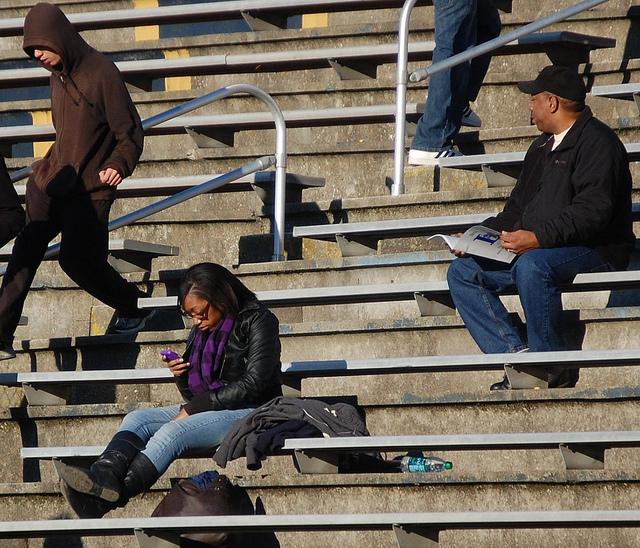Is the man paying attention to his book?
Quick response, please. No. What is the color of the girl's cell phone?
Concise answer only. Purple. Could this be a stadium?
Keep it brief. Yes. 